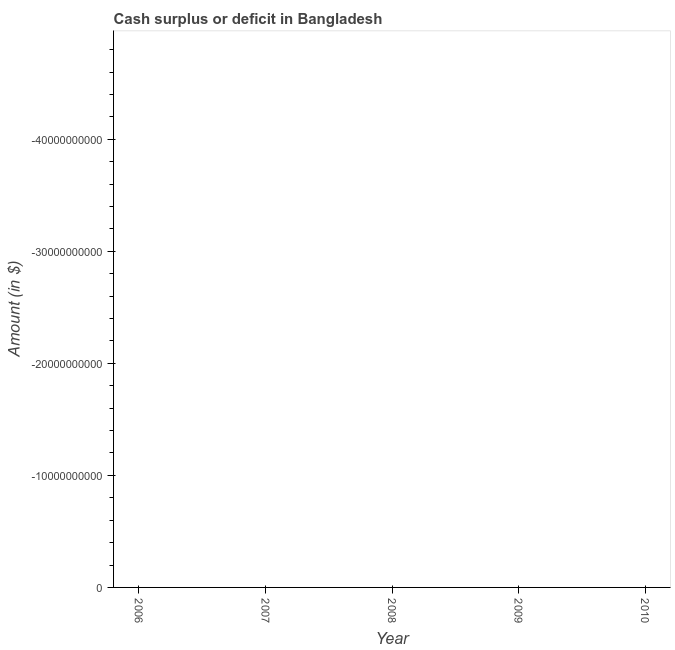What is the cash surplus or deficit in 2007?
Your answer should be compact. 0. Across all years, what is the minimum cash surplus or deficit?
Offer a very short reply. 0. What is the sum of the cash surplus or deficit?
Provide a short and direct response. 0. In how many years, is the cash surplus or deficit greater than -48000000000 $?
Offer a very short reply. 0. What is the difference between two consecutive major ticks on the Y-axis?
Provide a succinct answer. 1.00e+1. Are the values on the major ticks of Y-axis written in scientific E-notation?
Provide a succinct answer. No. Does the graph contain grids?
Give a very brief answer. No. What is the title of the graph?
Keep it short and to the point. Cash surplus or deficit in Bangladesh. What is the label or title of the X-axis?
Your answer should be very brief. Year. What is the label or title of the Y-axis?
Provide a succinct answer. Amount (in $). What is the Amount (in $) in 2007?
Keep it short and to the point. 0. What is the Amount (in $) in 2008?
Make the answer very short. 0. What is the Amount (in $) in 2009?
Provide a short and direct response. 0. What is the Amount (in $) in 2010?
Keep it short and to the point. 0. 